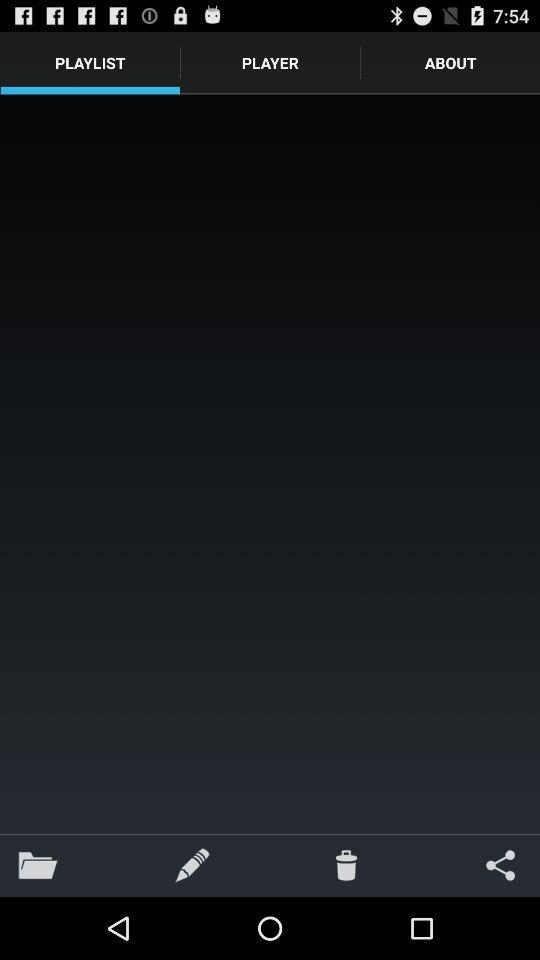Which tab is selected? The selected tab is "Playlist". 